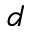Convert formula to latex. <formula><loc_0><loc_0><loc_500><loc_500>d</formula> 